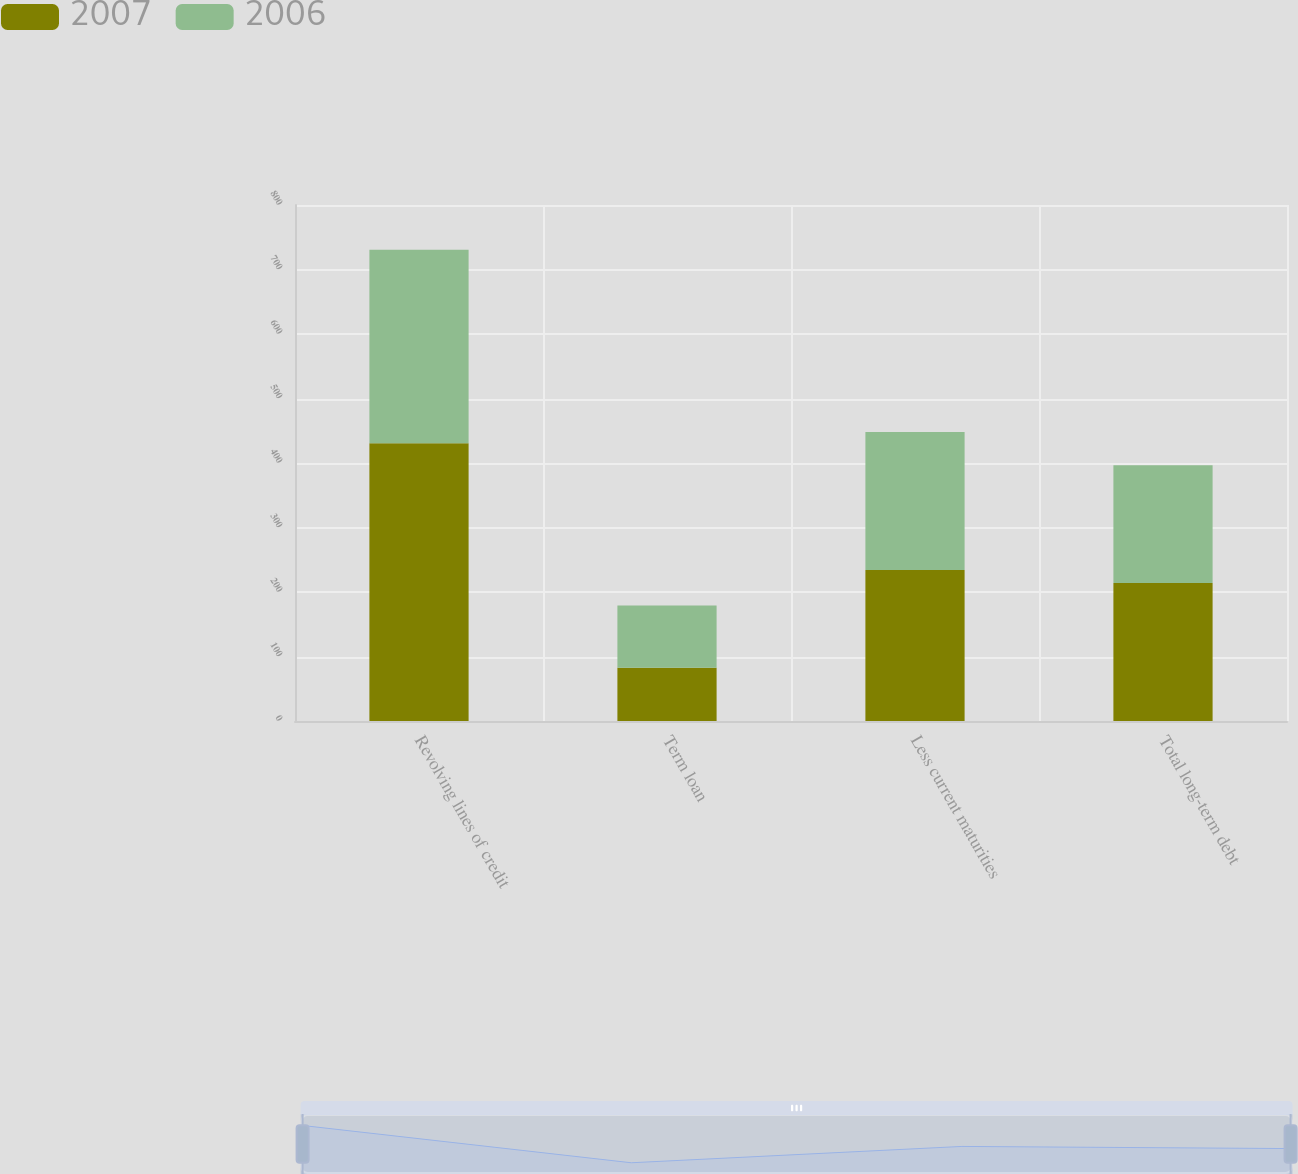Convert chart. <chart><loc_0><loc_0><loc_500><loc_500><stacked_bar_chart><ecel><fcel>Revolving lines of credit<fcel>Term loan<fcel>Less current maturities<fcel>Total long-term debt<nl><fcel>2007<fcel>430.6<fcel>82.5<fcel>234<fcel>214<nl><fcel>2006<fcel>299.9<fcel>96.5<fcel>214<fcel>182.4<nl></chart> 